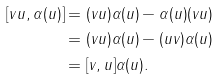<formula> <loc_0><loc_0><loc_500><loc_500>[ v u , \alpha ( u ) ] & = ( v u ) \alpha ( u ) - \alpha ( u ) ( v u ) \\ & = ( v u ) \alpha ( u ) - ( u v ) \alpha ( u ) \\ & = [ v , u ] \alpha ( u ) .</formula> 